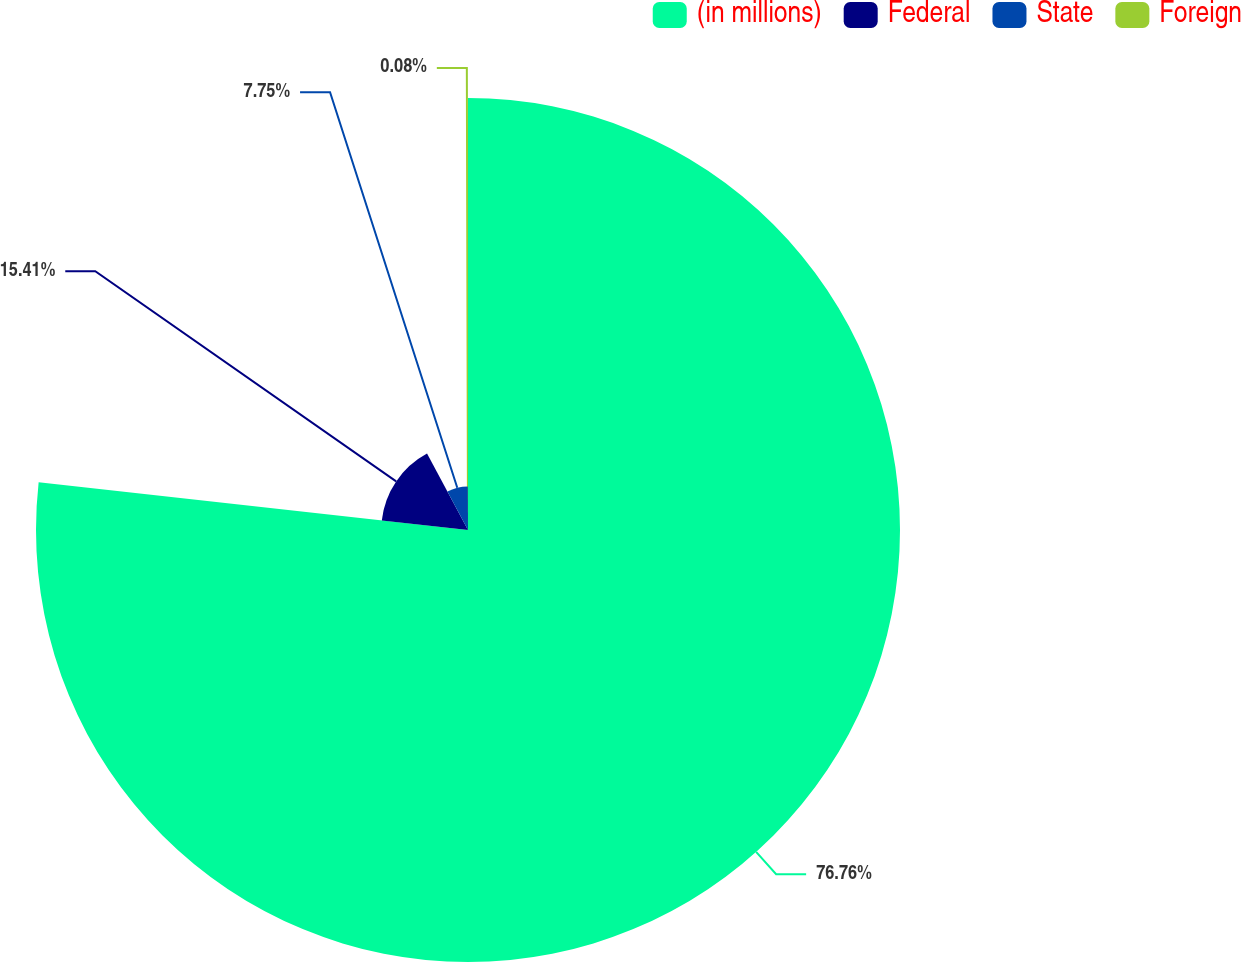<chart> <loc_0><loc_0><loc_500><loc_500><pie_chart><fcel>(in millions)<fcel>Federal<fcel>State<fcel>Foreign<nl><fcel>76.76%<fcel>15.41%<fcel>7.75%<fcel>0.08%<nl></chart> 